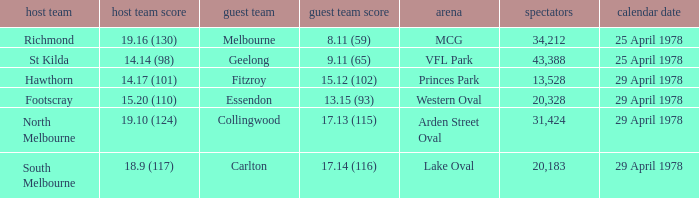What was the away team that played at Princes Park? Fitzroy. 